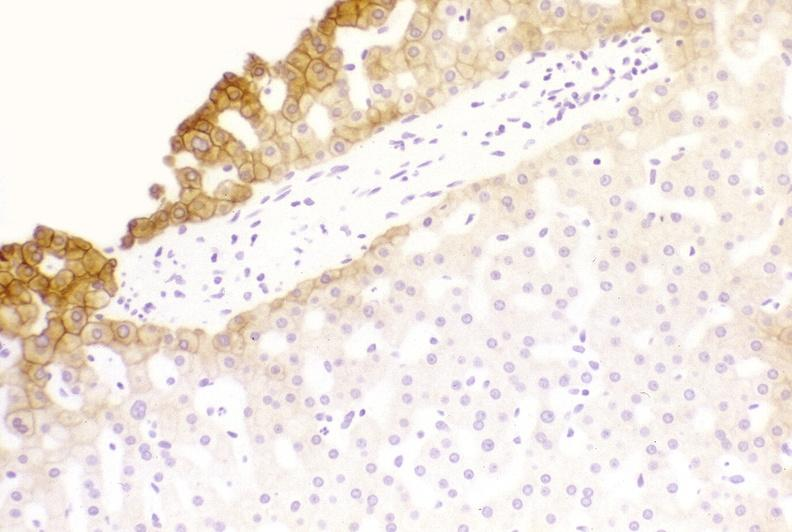s metastatic lung carcinoma present?
Answer the question using a single word or phrase. No 